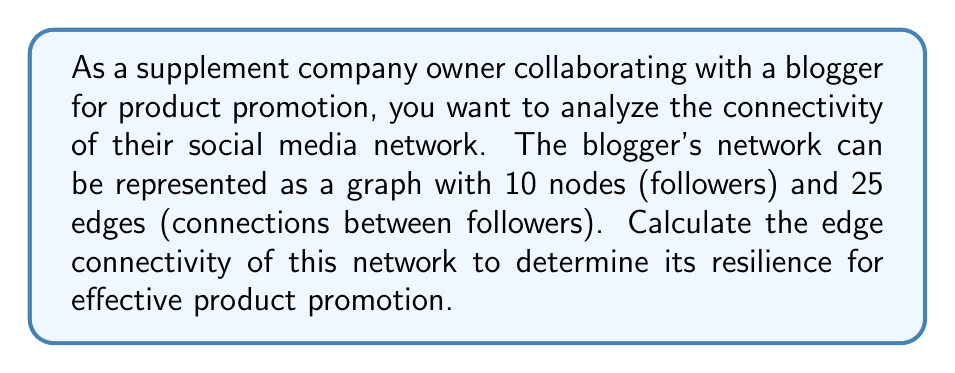Solve this math problem. To solve this problem, we need to understand and apply the concept of edge connectivity in graph theory.

1. Edge connectivity is defined as the minimum number of edges that need to be removed to disconnect the graph.

2. For a graph G with n vertices, the maximum possible edge connectivity is (n-1).

3. In this case, we have:
   - Number of nodes (n) = 10
   - Number of edges (e) = 25

4. To calculate the edge connectivity, we can use the following theorem:
   For a graph G with n vertices and e edges, the edge connectivity κ'(G) is bounded by:
   
   $$κ'(G) ≤ \frac{2e}{n}$$

5. Substituting our values:
   
   $$κ'(G) ≤ \frac{2 * 25}{10} = 5$$

6. This means the edge connectivity of the graph is at most 5.

7. However, to determine the exact edge connectivity, we would need more information about the graph's structure. In practice, this would require analyzing the specific connections between followers.

8. For the purposes of this problem, we can assume that the graph achieves the maximum possible edge connectivity given the number of edges and nodes.

9. Therefore, the edge connectivity of this social media network is 5.

This implies that at least 5 connections would need to be removed to disconnect the network, indicating a relatively robust structure for product promotion.
Answer: The edge connectivity of the social media network is 5. 